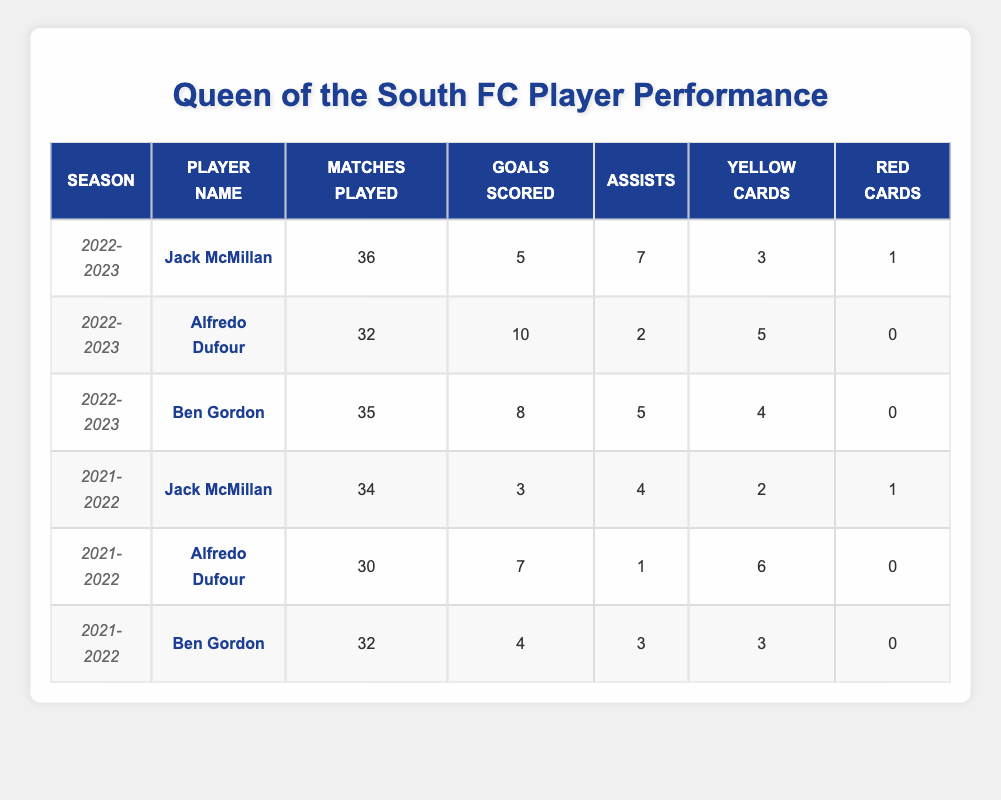What is the total number of goals scored by Jack McMillan across both seasons? Jack McMillan scored 5 goals in the 2022-2023 season and 3 goals in the 2021-2022 season. Adding these, 5 + 3 = 8.
Answer: 8 Which player had the most assists in the 2022-2023 season? In the 2022-2023 season, Jack McMillan had 7 assists, Ben Gordon had 5 assists, and Alfredo Dufour had 2 assists. Jack McMillan had the highest number of assists.
Answer: Jack McMillan Did Alfredo Dufour receive any red cards in the 2021-2022 season? Alfredo Dufour had 0 red cards in the 2021-2022 season as listed in the table.
Answer: No What is the difference in total matches played by Ben Gordon between the two seasons? Ben Gordon played 35 matches in the 2022-2023 season and 32 matches in the 2021-2022 season. The difference is 35 - 32 = 3 matches.
Answer: 3 Which player had the highest number of yellow cards in the 2022-2023 season? In the 2022-2023 season, Jack McMillan had 3 yellow cards, Ben Gordon had 4 yellow cards, and Alfredo Dufour had 5 yellow cards. Therefore, Alfredo Dufour had the highest number of yellow cards.
Answer: Alfredo Dufour What is the total number of assists made by all players in the 2021-2022 season? For the 2021-2022 season, Jack McMillan had 4 assists, Alfredo Dufour had 1 assist, and Ben Gordon had 3 assists. Summing these gives 4 + 1 + 3 = 8 assists total.
Answer: 8 Is the average number of goals scored by Ben Gordon higher in the 2021-2022 season compared to the 2022-2023 season? Ben Gordon scored 4 goals in the 2021-2022 season and 8 goals in the 2022-2023 season. The average for both seasons is (4 + 8)/2 = 6, but comparing the individual seasons shows he scored more in 2022-2023 (8 vs. 4).
Answer: No Who is the player with the least number of matches played in the 2021-2022 season? In the 2021-2022 season, Jack McMillan played 34 matches, Alfredo Dufour played 30 matches, and Ben Gordon played 32 matches. Alfredo Dufour played the least matches.
Answer: Alfredo Dufour What is the total number of cards received by Jack McMillan over both seasons? Jack McMillan received 3 yellow cards and 1 red card in the 2022-2023 season, and 2 yellow cards and 1 red card in the 2021-2022 season. Total cards = 3 + 1 + 2 + 1 = 7 cards.
Answer: 7 